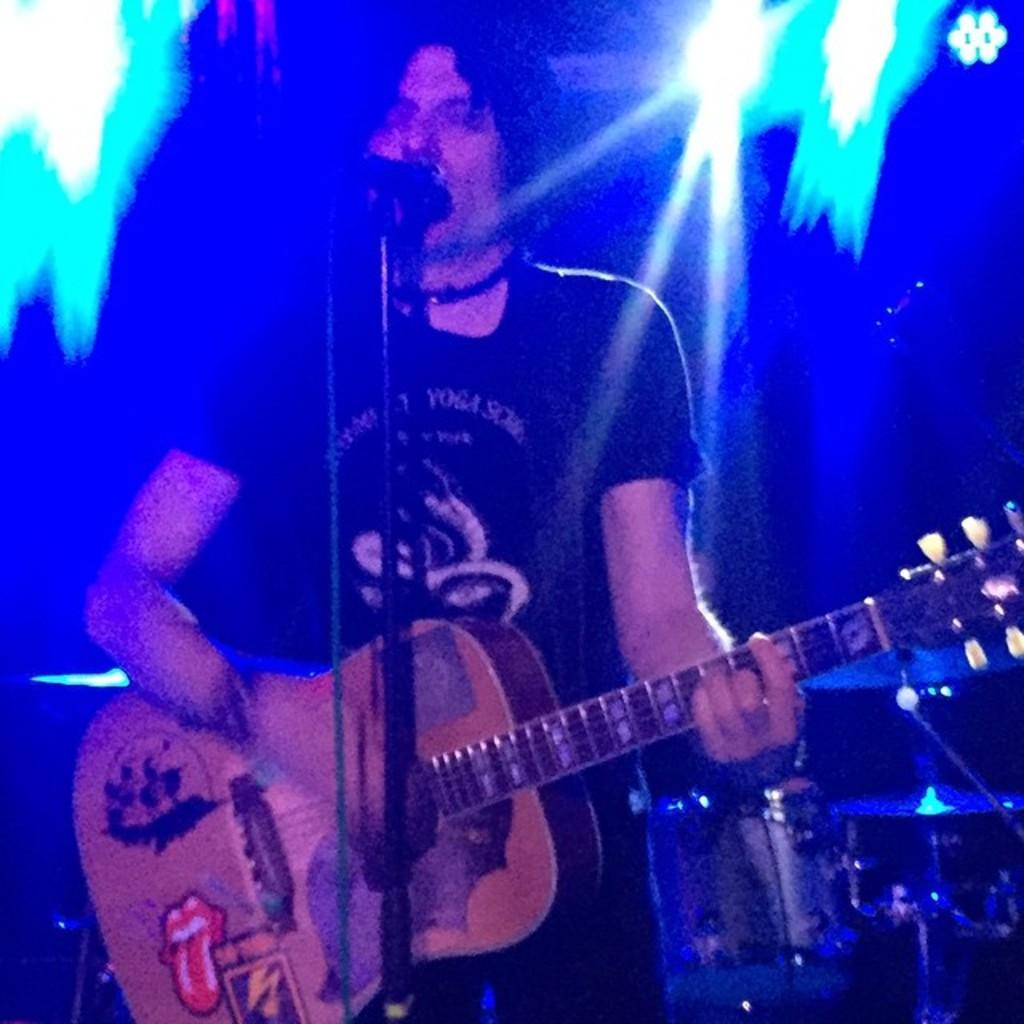What type of event is taking place in the image? It is a music concert. What instrument is the person holding in the image? The person is holding a guitar. What is the person doing with the guitar? The person is playing the guitar. What is the person doing in addition to playing the guitar? The person is singing. What is used to amplify the person's voice during the performance? There is a microphone in front of the person. What can be seen in the background of the image? There are lights and drums in the background. What type of road is visible in the image? There is no road visible in the image; it is a music concert with a focus on the performer and their instruments. What position does the person hold in the band? The image does not provide enough information to determine the person's position in the band. 